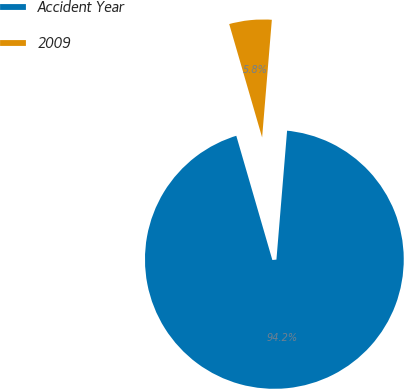Convert chart to OTSL. <chart><loc_0><loc_0><loc_500><loc_500><pie_chart><fcel>Accident Year<fcel>2009<nl><fcel>94.19%<fcel>5.81%<nl></chart> 